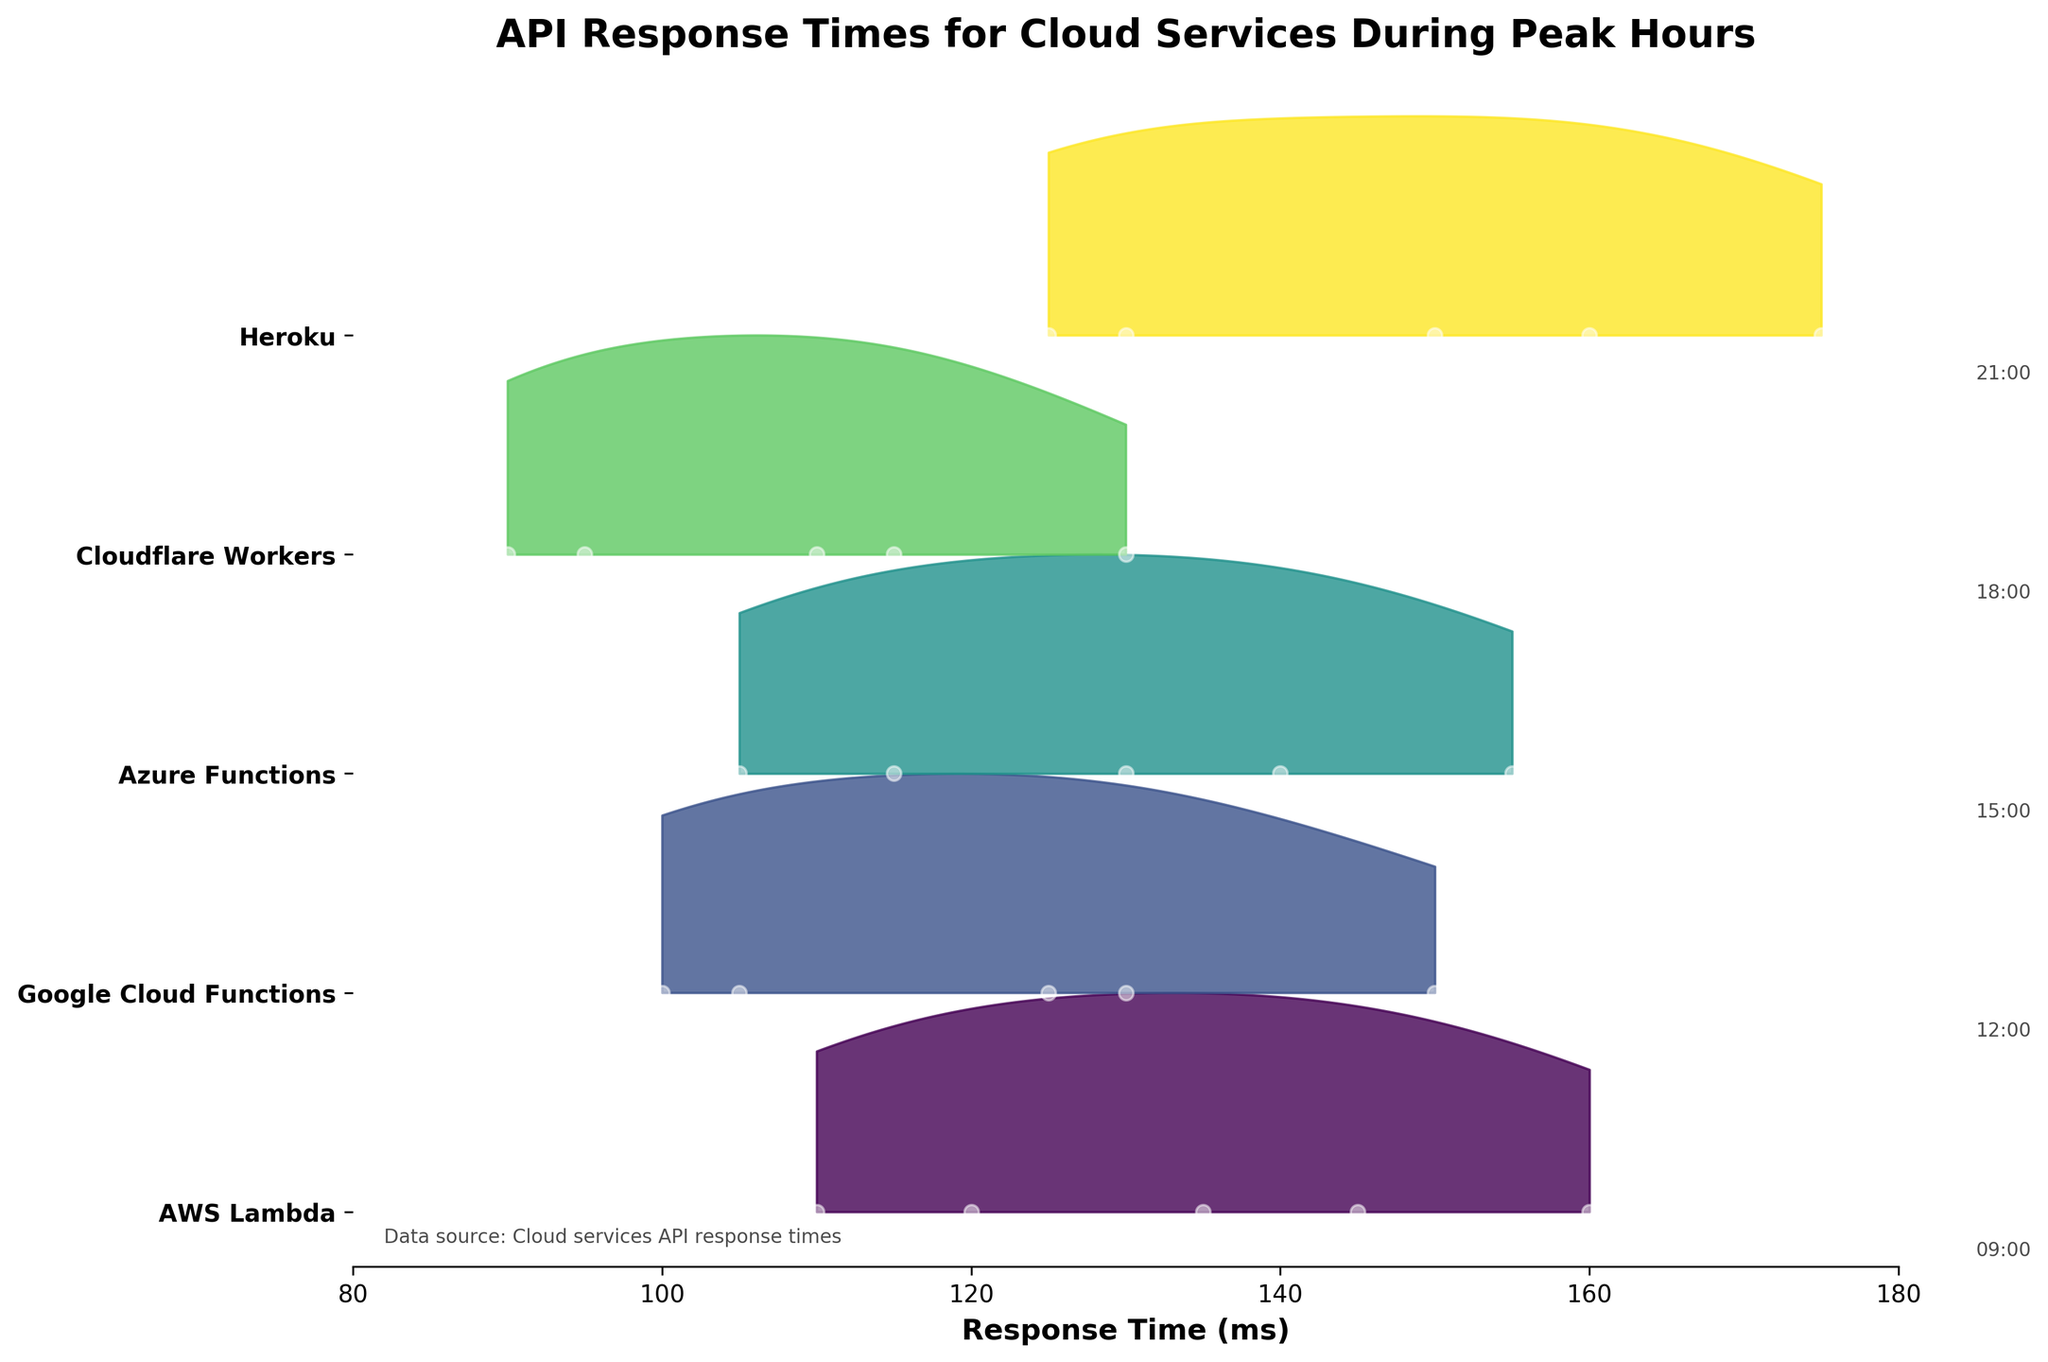What is the title of the figure? The title is often at the top of the plot and explicitly mentions what the data is about.
Answer: API Response Times for Cloud Services During Peak Hours Which cloud service has the lowest response time at 21:00? By examining the plot's right-side for the time label and the corresponding response time for each service, the lowest data point at that hour is checked.
Answer: Cloudflare Workers How does the response time of Heroku compare to AWS Lambda at 15:00? Locate the data points for Heroku and AWS Lambda at 15:00 on the plot and compare their values.
Answer: Heroku has a higher response time than AWS Lambda What is the average response time of Google Cloud Functions? Identify the response times of Google Cloud Functions at all given times and calculate their average. (105 + 130 + 150 + 125 + 100) / 5 = 122
Answer: 122 ms What time period shows the highest response time for Azure Functions? Locate Azure Functions data on the ridgeline and find the peak value among the different hours.
Answer: 15:00 Which service consistently shows the lowest response times across different times? Compare the general trend and lowest points across the times for each service displayed in the plot.
Answer: Cloudflare Workers Are there any services that show response times over 170 ms? Look for values above 170 ms on the x-axis for each service's plotted data points or density region.
Answer: Only Heroku Between Google Cloud Functions and Azure Functions, which shows more variability in response times? Assess the spread of response times visually for each service, considering the width of the density curves at different times.
Answer: Google Cloud Functions What is the peak response time for AWS Lambda and at what time does it occur? Check the highest data point for AWS Lambda on the ridgeline and note the corresponding time.
Answer: 160 ms at 15:00 